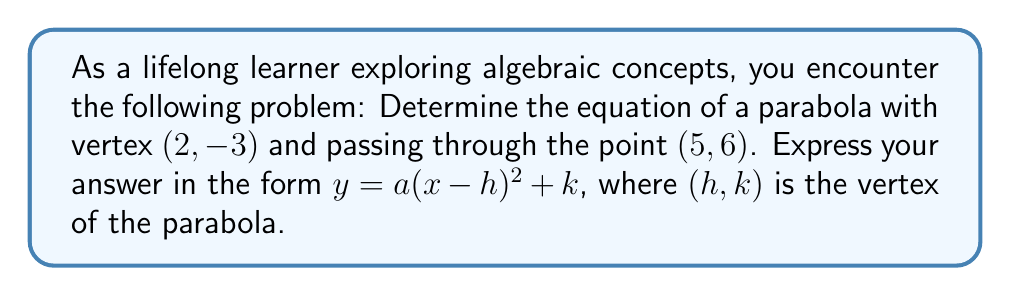Give your solution to this math problem. Let's approach this step-by-step:

1) We know the general form of a parabola with vertex $(h, k)$ is:
   $y = a(x - h)^2 + k$

2) We're given the vertex $(2, -3)$, so $h = 2$ and $k = -3$. Substituting these:
   $y = a(x - 2)^2 - 3$

3) Now we need to find $a$. We can use the point $(5, 6)$ that the parabola passes through:
   $6 = a(5 - 2)^2 - 3$

4) Simplify:
   $6 = a(3)^2 - 3$
   $6 = 9a - 3$

5) Solve for $a$:
   $9 = 9a$
   $a = 1$

6) Now that we have $a$, we can write the final equation:
   $y = 1(x - 2)^2 - 3$

7) This can be simplified to:
   $y = (x - 2)^2 - 3$

This is our final equation in the form $y = a(x - h)^2 + k$.
Answer: $y = (x - 2)^2 - 3$ 